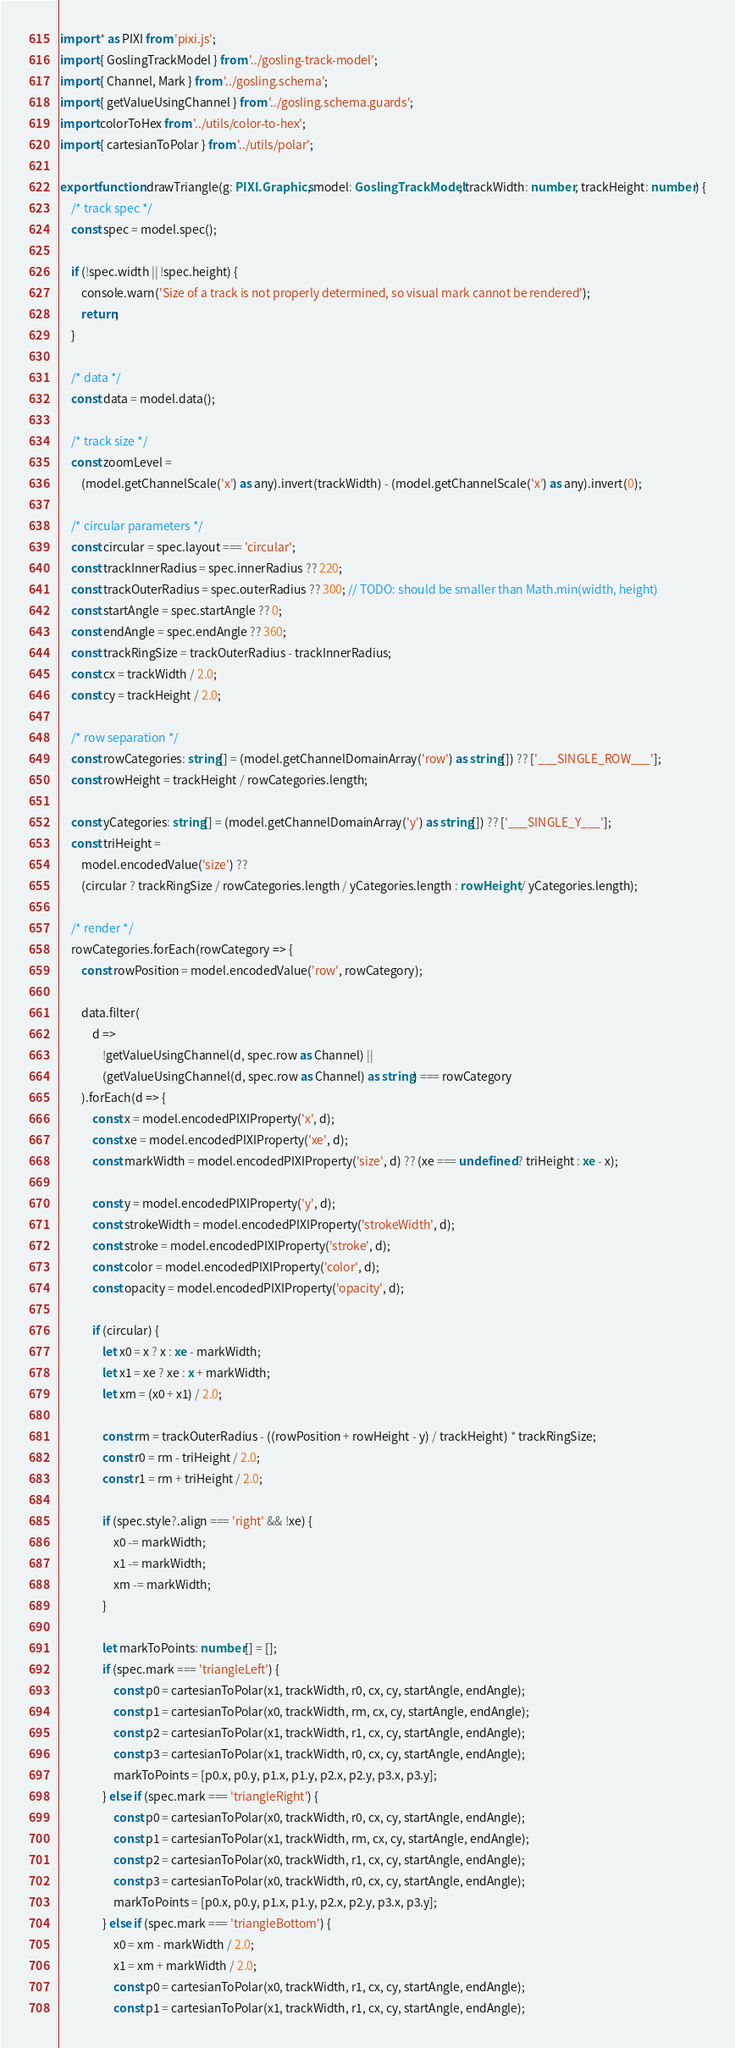Convert code to text. <code><loc_0><loc_0><loc_500><loc_500><_TypeScript_>import * as PIXI from 'pixi.js';
import { GoslingTrackModel } from '../gosling-track-model';
import { Channel, Mark } from '../gosling.schema';
import { getValueUsingChannel } from '../gosling.schema.guards';
import colorToHex from '../utils/color-to-hex';
import { cartesianToPolar } from '../utils/polar';

export function drawTriangle(g: PIXI.Graphics, model: GoslingTrackModel, trackWidth: number, trackHeight: number) {
    /* track spec */
    const spec = model.spec();

    if (!spec.width || !spec.height) {
        console.warn('Size of a track is not properly determined, so visual mark cannot be rendered');
        return;
    }

    /* data */
    const data = model.data();

    /* track size */
    const zoomLevel =
        (model.getChannelScale('x') as any).invert(trackWidth) - (model.getChannelScale('x') as any).invert(0);

    /* circular parameters */
    const circular = spec.layout === 'circular';
    const trackInnerRadius = spec.innerRadius ?? 220;
    const trackOuterRadius = spec.outerRadius ?? 300; // TODO: should be smaller than Math.min(width, height)
    const startAngle = spec.startAngle ?? 0;
    const endAngle = spec.endAngle ?? 360;
    const trackRingSize = trackOuterRadius - trackInnerRadius;
    const cx = trackWidth / 2.0;
    const cy = trackHeight / 2.0;

    /* row separation */
    const rowCategories: string[] = (model.getChannelDomainArray('row') as string[]) ?? ['___SINGLE_ROW___'];
    const rowHeight = trackHeight / rowCategories.length;

    const yCategories: string[] = (model.getChannelDomainArray('y') as string[]) ?? ['___SINGLE_Y___'];
    const triHeight =
        model.encodedValue('size') ??
        (circular ? trackRingSize / rowCategories.length / yCategories.length : rowHeight / yCategories.length);

    /* render */
    rowCategories.forEach(rowCategory => {
        const rowPosition = model.encodedValue('row', rowCategory);

        data.filter(
            d =>
                !getValueUsingChannel(d, spec.row as Channel) ||
                (getValueUsingChannel(d, spec.row as Channel) as string) === rowCategory
        ).forEach(d => {
            const x = model.encodedPIXIProperty('x', d);
            const xe = model.encodedPIXIProperty('xe', d);
            const markWidth = model.encodedPIXIProperty('size', d) ?? (xe === undefined ? triHeight : xe - x);

            const y = model.encodedPIXIProperty('y', d);
            const strokeWidth = model.encodedPIXIProperty('strokeWidth', d);
            const stroke = model.encodedPIXIProperty('stroke', d);
            const color = model.encodedPIXIProperty('color', d);
            const opacity = model.encodedPIXIProperty('opacity', d);

            if (circular) {
                let x0 = x ? x : xe - markWidth;
                let x1 = xe ? xe : x + markWidth;
                let xm = (x0 + x1) / 2.0;

                const rm = trackOuterRadius - ((rowPosition + rowHeight - y) / trackHeight) * trackRingSize;
                const r0 = rm - triHeight / 2.0;
                const r1 = rm + triHeight / 2.0;

                if (spec.style?.align === 'right' && !xe) {
                    x0 -= markWidth;
                    x1 -= markWidth;
                    xm -= markWidth;
                }

                let markToPoints: number[] = [];
                if (spec.mark === 'triangleLeft') {
                    const p0 = cartesianToPolar(x1, trackWidth, r0, cx, cy, startAngle, endAngle);
                    const p1 = cartesianToPolar(x0, trackWidth, rm, cx, cy, startAngle, endAngle);
                    const p2 = cartesianToPolar(x1, trackWidth, r1, cx, cy, startAngle, endAngle);
                    const p3 = cartesianToPolar(x1, trackWidth, r0, cx, cy, startAngle, endAngle);
                    markToPoints = [p0.x, p0.y, p1.x, p1.y, p2.x, p2.y, p3.x, p3.y];
                } else if (spec.mark === 'triangleRight') {
                    const p0 = cartesianToPolar(x0, trackWidth, r0, cx, cy, startAngle, endAngle);
                    const p1 = cartesianToPolar(x1, trackWidth, rm, cx, cy, startAngle, endAngle);
                    const p2 = cartesianToPolar(x0, trackWidth, r1, cx, cy, startAngle, endAngle);
                    const p3 = cartesianToPolar(x0, trackWidth, r0, cx, cy, startAngle, endAngle);
                    markToPoints = [p0.x, p0.y, p1.x, p1.y, p2.x, p2.y, p3.x, p3.y];
                } else if (spec.mark === 'triangleBottom') {
                    x0 = xm - markWidth / 2.0;
                    x1 = xm + markWidth / 2.0;
                    const p0 = cartesianToPolar(x0, trackWidth, r1, cx, cy, startAngle, endAngle);
                    const p1 = cartesianToPolar(x1, trackWidth, r1, cx, cy, startAngle, endAngle);</code> 